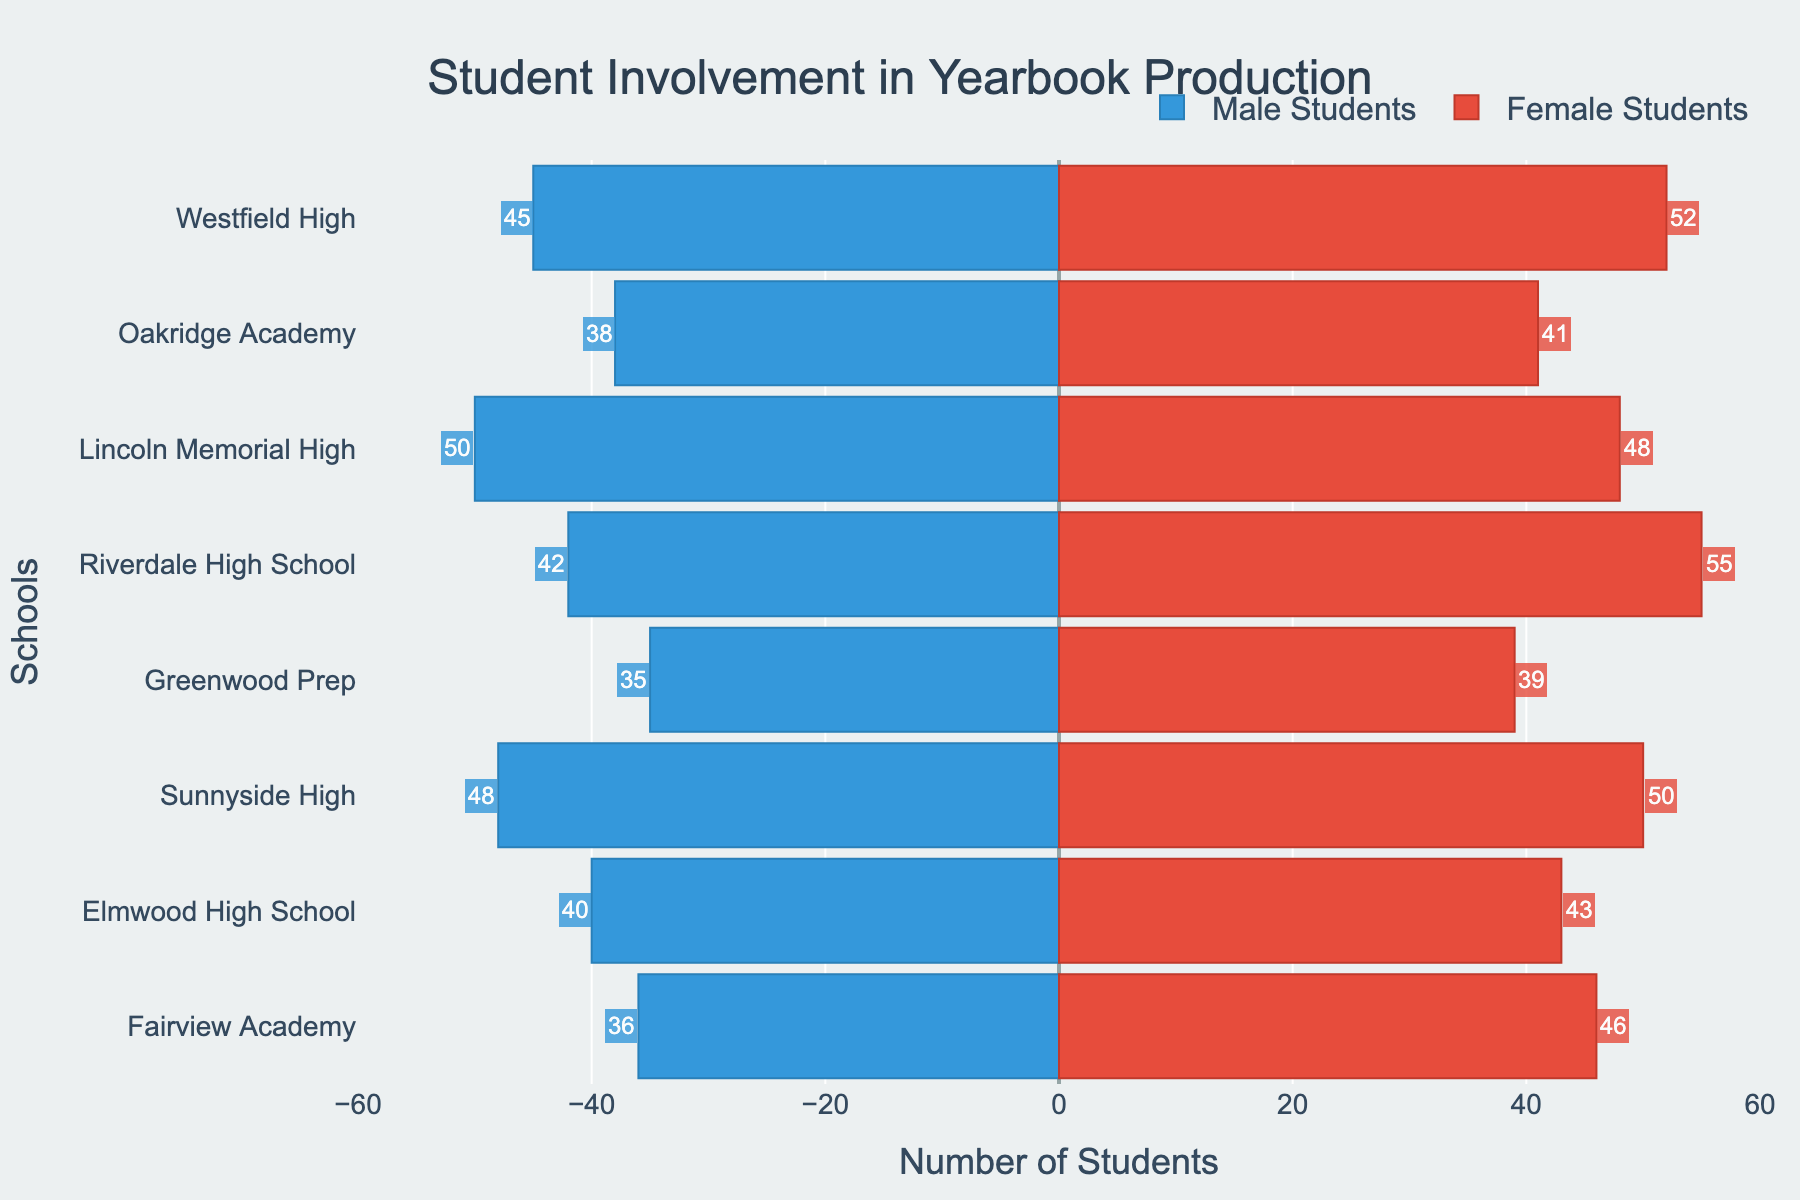Which school has the highest number of female students involved in yearbook production? To find the school with the highest number of female students, look at the red bars representing female students. The longest red bar corresponds to Riverdale High School.
Answer: Riverdale High School How many students in total from Elmwood High School are involved in yearbook production? To get the total number of students from Elmwood High School, sum the number of male and female students. Elmwood High School has 40 male students and 43 female students. 40 + 43 = 83
Answer: 83 Which school has more male than female students involved in yearbook production? To identify this, look for schools where the blue bar (males) is longer than the red bar (females). Lincoln Memorial High has 50 male students and 48 female students, which fits this criteria.
Answer: Lincoln Memorial High What is the difference in student involvement between the school with the most students and the school with the fewest students? Calculate the total number of students for each school and find the difference between the highest and lowest totals. Riverdale High School has the most students (42 + 55 = 97) and Greenwood Prep has the fewest (35 + 39 = 74). The difference is 97 - 74.
Answer: 23 Compare the total number of male students at Westfield High and Lincoln Memorial High. Which school has more, and by how much? Westfield High has 45 male students and Lincoln Memorial High has 50. Compare these two values. 50 - 45 = 5. Lincoln Memorial High has 5 more male students than Westfield High.
Answer: Lincoln Memorial High by 5 Which school has the closest number of male and female students involved in yearbook production? To find this, look for the smallest difference between the number of male and female students for each school. Sunnyside High has 48 male and 50 female students. The difference is 2, which is the smallest difference in the dataset.
Answer: Sunnyside High How many female students in total are involved in yearbook production across all schools? Sum the number of female students from all schools. 52 + 41 + 48 + 55 + 39 + 50 + 43 + 46 = 374
Answer: 374 What is the gender ratio of student involvement at Fairview Academy? To find the gender ratio (Male:Female) at Fairview Academy, compare the number of male and female students. Fairview Academy has 36 male and 46 female students. The ratio is 36:46. Simplify by dividing both numbers by their greatest common divisor, 2.
Answer: 18:23 Which school has the smallest student involvement in yearbook production, and how many students are involved? Sum the number of male and female students for each school to find the school with the smallest total. Greenwood Prep has the smallest total (35 + 39 = 74 students).
Answer: Greenwood Prep with 74 students What is the total number of male students involved in yearbook production across the district? Sum the number of male students from each school. 45 + 38 + 50 + 42 + 35 + 48 + 40 + 36 = 334
Answer: 334 